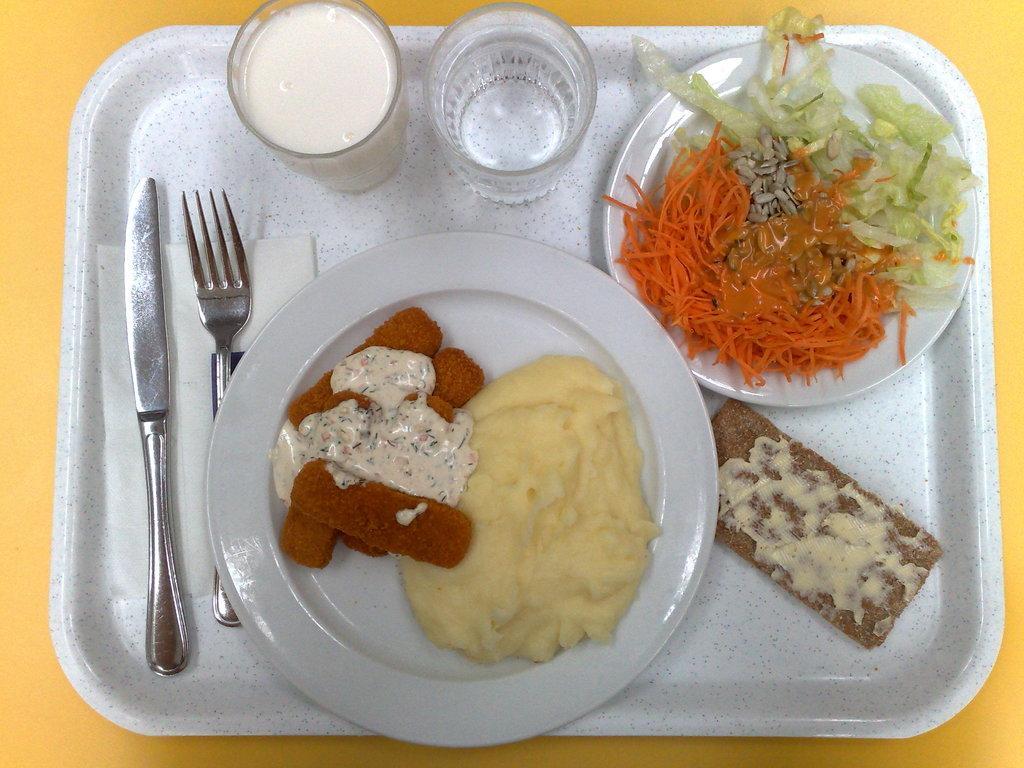Please provide a concise description of this image. In this image there is a tray , on the tray there are two glasses , two plates, on top of plates contain food items, there is a tissue paper, spoon , fork all are kept on tray , tray is kept on table. 